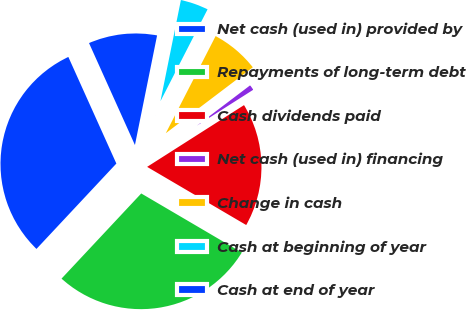Convert chart. <chart><loc_0><loc_0><loc_500><loc_500><pie_chart><fcel>Net cash (used in) provided by<fcel>Repayments of long-term debt<fcel>Cash dividends paid<fcel>Net cash (used in) financing<fcel>Change in cash<fcel>Cash at beginning of year<fcel>Cash at end of year<nl><fcel>31.3%<fcel>28.53%<fcel>17.48%<fcel>1.29%<fcel>7.14%<fcel>4.37%<fcel>9.91%<nl></chart> 